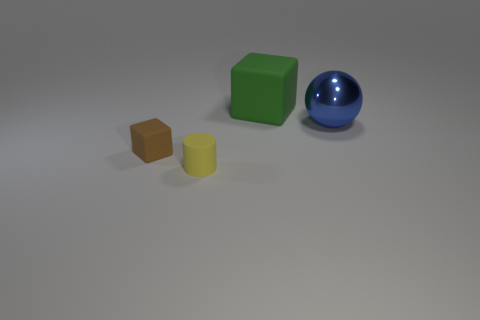Add 4 small shiny cylinders. How many objects exist? 8 Subtract all balls. How many objects are left? 3 Subtract all tiny gray things. Subtract all brown rubber things. How many objects are left? 3 Add 4 small yellow objects. How many small yellow objects are left? 5 Add 2 green rubber blocks. How many green rubber blocks exist? 3 Subtract 0 blue blocks. How many objects are left? 4 